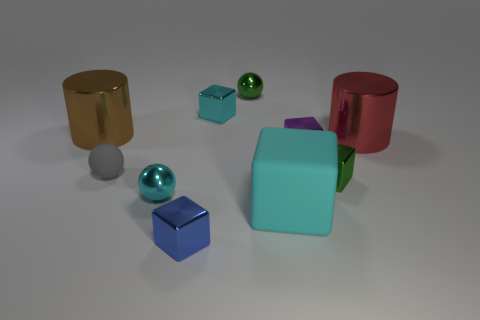There is a cyan object that is the same material as the small cyan sphere; what is its shape?
Your answer should be compact. Cube. What number of other objects are the same shape as the big red thing?
Make the answer very short. 1. There is a small green metal thing that is left of the purple object; what shape is it?
Your response must be concise. Sphere. The large matte object has what color?
Make the answer very short. Cyan. What number of other objects are the same size as the cyan ball?
Keep it short and to the point. 6. What is the material of the big object in front of the large thing on the right side of the tiny purple metal cube?
Offer a very short reply. Rubber. There is a blue metallic block; is its size the same as the green object that is in front of the large red metal cylinder?
Provide a short and direct response. Yes. Is there a object that has the same color as the big matte cube?
Keep it short and to the point. Yes. How many small things are either gray cylinders or blocks?
Offer a very short reply. 4. What number of cyan objects are there?
Offer a terse response. 3. 